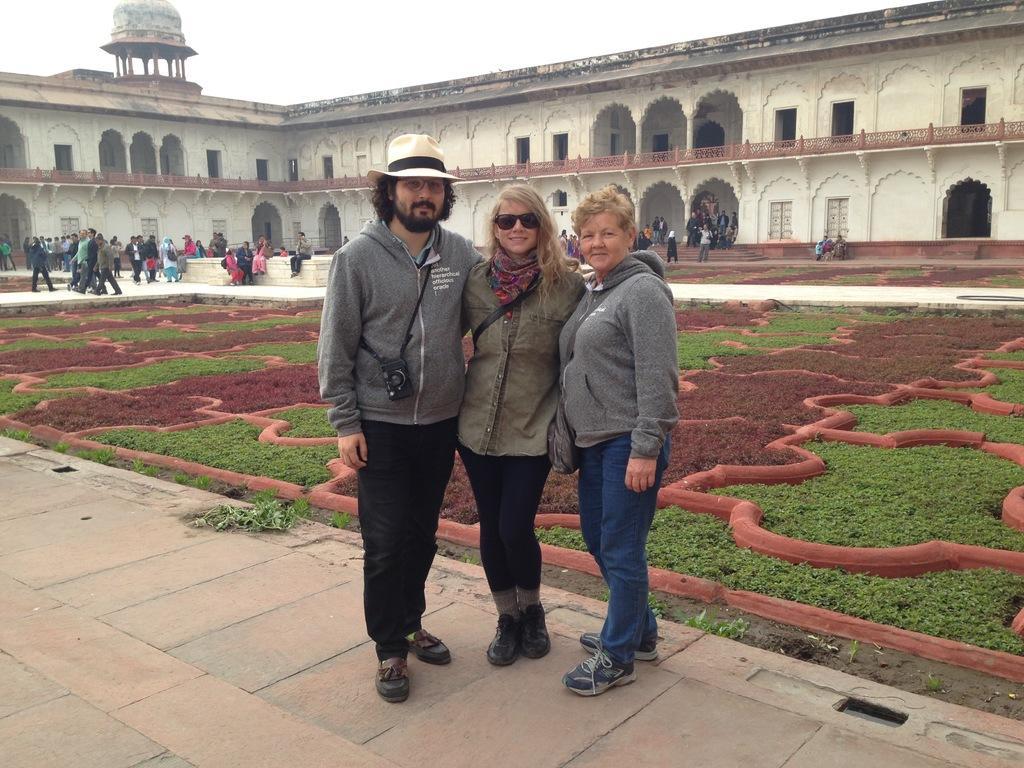How would you summarize this image in a sentence or two? In this image I can see group of people, some are sitting and some are walking. In front I can see three persons standing, the person at left is wearing grey and black color dress and I can also see the camera. Background I can see the building in white and brown color and the sky is in white color. 